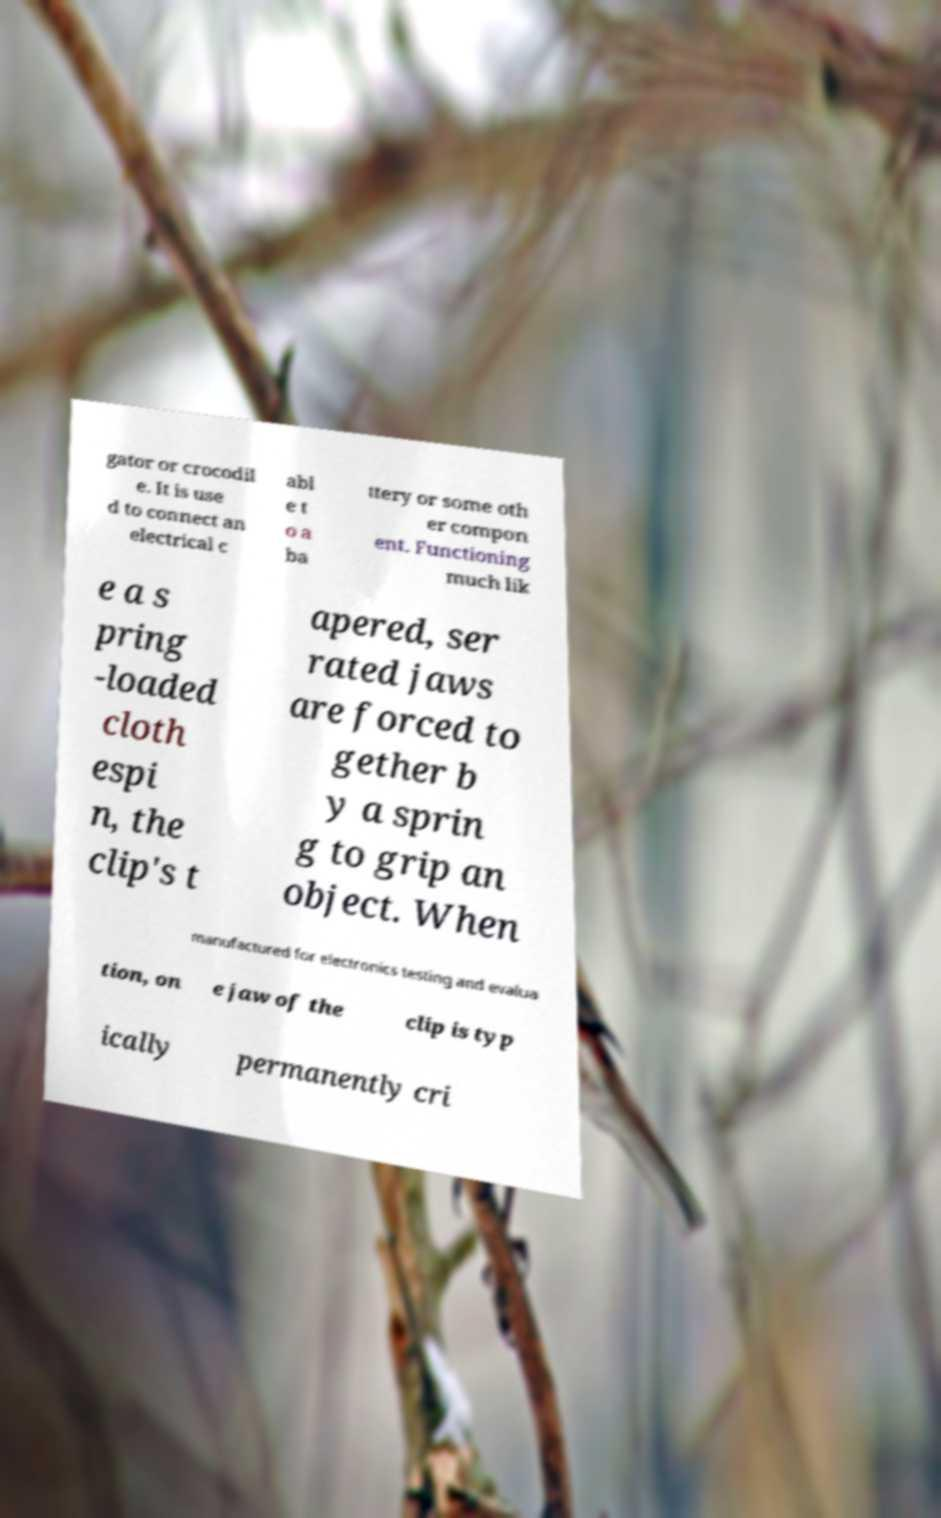What messages or text are displayed in this image? I need them in a readable, typed format. gator or crocodil e. It is use d to connect an electrical c abl e t o a ba ttery or some oth er compon ent. Functioning much lik e a s pring -loaded cloth espi n, the clip's t apered, ser rated jaws are forced to gether b y a sprin g to grip an object. When manufactured for electronics testing and evalua tion, on e jaw of the clip is typ ically permanently cri 